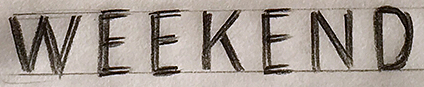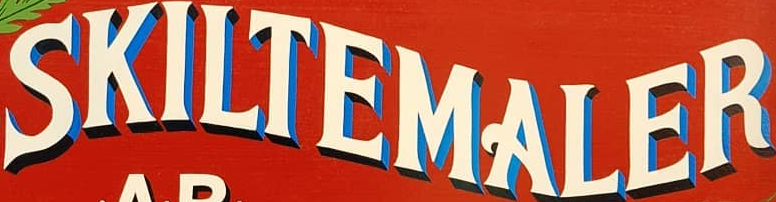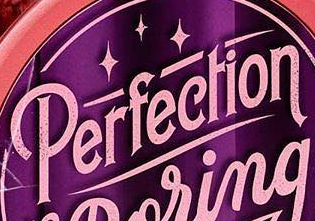Read the text from these images in sequence, separated by a semicolon. WEEKEND; SKILTEMALER; Perfection 